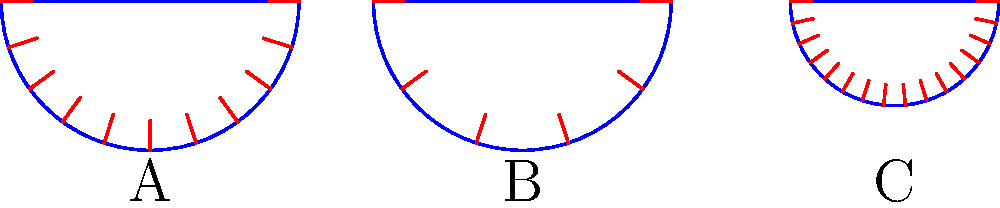Based on the stress distribution diagrams shown for three different dome shapes (A, B, and C), which shape would be most efficient for constructing a large-scale religious dome to maximize durability and structural integrity? To determine the most efficient structural shape for a religious dome, we need to analyze the stress distribution in each shape:

1. Shape A:
   - Semicircular dome
   - Stress lines are evenly distributed
   - Moderate number of stress lines (10)

2. Shape B:
   - Semicircular dome (similar to A)
   - Fewer stress lines (5)
   - Larger gaps between stress lines indicate less uniform stress distribution

3. Shape C:
   - Shallower dome (lower height-to-width ratio)
   - More stress lines (15)
   - Stress lines are more closely packed, indicating higher stress concentration

Analyzing these shapes:

1. Even stress distribution is preferable for structural integrity.
2. A moderate number of stress lines indicates a balance between load-bearing capacity and material efficiency.
3. The shape of the dome affects stress distribution; semicircular domes typically perform well.

Shape A demonstrates the most favorable characteristics:
- Semicircular shape provides natural strength
- Even distribution of stress lines indicates uniform load distribution
- Moderate number of stress lines suggests efficient use of materials while maintaining strength

Shape B has fewer stress lines, which might indicate less efficient load distribution.
Shape C's shallower profile and higher stress line concentration suggest potential weak points and higher material stress.

Therefore, Shape A would be the most efficient for constructing a large-scale religious dome, maximizing durability and structural integrity.
Answer: Shape A 